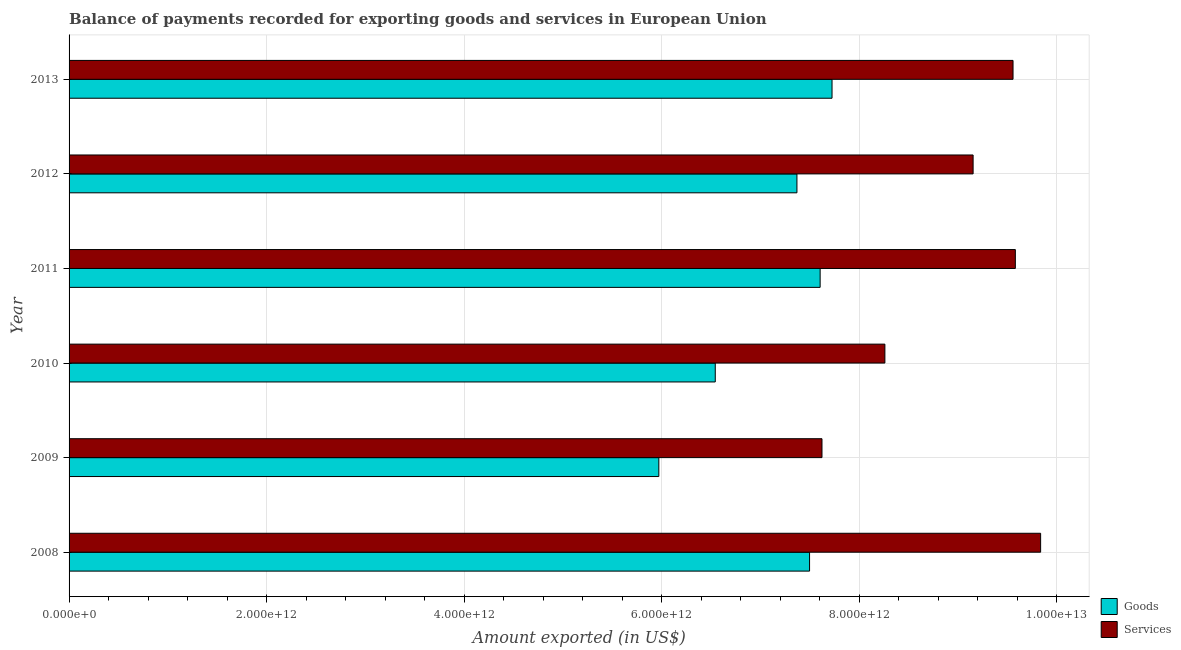Are the number of bars per tick equal to the number of legend labels?
Your answer should be very brief. Yes. How many bars are there on the 1st tick from the bottom?
Offer a terse response. 2. What is the amount of services exported in 2012?
Offer a terse response. 9.15e+12. Across all years, what is the maximum amount of services exported?
Keep it short and to the point. 9.84e+12. Across all years, what is the minimum amount of services exported?
Your response must be concise. 7.62e+12. What is the total amount of services exported in the graph?
Give a very brief answer. 5.40e+13. What is the difference between the amount of goods exported in 2011 and that in 2012?
Make the answer very short. 2.35e+11. What is the difference between the amount of goods exported in 2013 and the amount of services exported in 2011?
Your answer should be very brief. -1.86e+12. What is the average amount of goods exported per year?
Offer a terse response. 7.12e+12. In the year 2012, what is the difference between the amount of goods exported and amount of services exported?
Give a very brief answer. -1.78e+12. In how many years, is the amount of services exported greater than 6400000000000 US$?
Offer a terse response. 6. What is the ratio of the amount of services exported in 2008 to that in 2009?
Your answer should be very brief. 1.29. Is the amount of services exported in 2008 less than that in 2013?
Provide a succinct answer. No. Is the difference between the amount of services exported in 2011 and 2012 greater than the difference between the amount of goods exported in 2011 and 2012?
Keep it short and to the point. Yes. What is the difference between the highest and the second highest amount of services exported?
Provide a short and direct response. 2.56e+11. What is the difference between the highest and the lowest amount of services exported?
Give a very brief answer. 2.21e+12. Is the sum of the amount of services exported in 2008 and 2012 greater than the maximum amount of goods exported across all years?
Ensure brevity in your answer.  Yes. What does the 2nd bar from the top in 2012 represents?
Your response must be concise. Goods. What does the 2nd bar from the bottom in 2012 represents?
Provide a short and direct response. Services. How many bars are there?
Keep it short and to the point. 12. Are all the bars in the graph horizontal?
Keep it short and to the point. Yes. What is the difference between two consecutive major ticks on the X-axis?
Provide a succinct answer. 2.00e+12. Where does the legend appear in the graph?
Keep it short and to the point. Bottom right. How many legend labels are there?
Give a very brief answer. 2. How are the legend labels stacked?
Make the answer very short. Vertical. What is the title of the graph?
Your response must be concise. Balance of payments recorded for exporting goods and services in European Union. What is the label or title of the X-axis?
Offer a terse response. Amount exported (in US$). What is the Amount exported (in US$) of Goods in 2008?
Keep it short and to the point. 7.50e+12. What is the Amount exported (in US$) of Services in 2008?
Provide a succinct answer. 9.84e+12. What is the Amount exported (in US$) of Goods in 2009?
Give a very brief answer. 5.97e+12. What is the Amount exported (in US$) of Services in 2009?
Give a very brief answer. 7.62e+12. What is the Amount exported (in US$) in Goods in 2010?
Offer a very short reply. 6.54e+12. What is the Amount exported (in US$) in Services in 2010?
Ensure brevity in your answer.  8.26e+12. What is the Amount exported (in US$) in Goods in 2011?
Make the answer very short. 7.60e+12. What is the Amount exported (in US$) in Services in 2011?
Your answer should be compact. 9.58e+12. What is the Amount exported (in US$) of Goods in 2012?
Your answer should be compact. 7.37e+12. What is the Amount exported (in US$) in Services in 2012?
Give a very brief answer. 9.15e+12. What is the Amount exported (in US$) in Goods in 2013?
Provide a succinct answer. 7.72e+12. What is the Amount exported (in US$) of Services in 2013?
Your answer should be very brief. 9.56e+12. Across all years, what is the maximum Amount exported (in US$) in Goods?
Provide a succinct answer. 7.72e+12. Across all years, what is the maximum Amount exported (in US$) in Services?
Your answer should be very brief. 9.84e+12. Across all years, what is the minimum Amount exported (in US$) of Goods?
Offer a terse response. 5.97e+12. Across all years, what is the minimum Amount exported (in US$) in Services?
Make the answer very short. 7.62e+12. What is the total Amount exported (in US$) in Goods in the graph?
Give a very brief answer. 4.27e+13. What is the total Amount exported (in US$) in Services in the graph?
Make the answer very short. 5.40e+13. What is the difference between the Amount exported (in US$) of Goods in 2008 and that in 2009?
Your response must be concise. 1.53e+12. What is the difference between the Amount exported (in US$) of Services in 2008 and that in 2009?
Give a very brief answer. 2.21e+12. What is the difference between the Amount exported (in US$) in Goods in 2008 and that in 2010?
Make the answer very short. 9.54e+11. What is the difference between the Amount exported (in US$) in Services in 2008 and that in 2010?
Offer a very short reply. 1.58e+12. What is the difference between the Amount exported (in US$) in Goods in 2008 and that in 2011?
Your answer should be very brief. -1.07e+11. What is the difference between the Amount exported (in US$) of Services in 2008 and that in 2011?
Offer a terse response. 2.56e+11. What is the difference between the Amount exported (in US$) of Goods in 2008 and that in 2012?
Make the answer very short. 1.28e+11. What is the difference between the Amount exported (in US$) in Services in 2008 and that in 2012?
Ensure brevity in your answer.  6.83e+11. What is the difference between the Amount exported (in US$) in Goods in 2008 and that in 2013?
Provide a succinct answer. -2.27e+11. What is the difference between the Amount exported (in US$) in Services in 2008 and that in 2013?
Keep it short and to the point. 2.79e+11. What is the difference between the Amount exported (in US$) of Goods in 2009 and that in 2010?
Provide a succinct answer. -5.71e+11. What is the difference between the Amount exported (in US$) of Services in 2009 and that in 2010?
Your answer should be compact. -6.37e+11. What is the difference between the Amount exported (in US$) in Goods in 2009 and that in 2011?
Provide a short and direct response. -1.63e+12. What is the difference between the Amount exported (in US$) in Services in 2009 and that in 2011?
Offer a very short reply. -1.96e+12. What is the difference between the Amount exported (in US$) of Goods in 2009 and that in 2012?
Make the answer very short. -1.40e+12. What is the difference between the Amount exported (in US$) of Services in 2009 and that in 2012?
Your answer should be compact. -1.53e+12. What is the difference between the Amount exported (in US$) of Goods in 2009 and that in 2013?
Ensure brevity in your answer.  -1.75e+12. What is the difference between the Amount exported (in US$) of Services in 2009 and that in 2013?
Provide a short and direct response. -1.93e+12. What is the difference between the Amount exported (in US$) in Goods in 2010 and that in 2011?
Keep it short and to the point. -1.06e+12. What is the difference between the Amount exported (in US$) in Services in 2010 and that in 2011?
Your response must be concise. -1.32e+12. What is the difference between the Amount exported (in US$) in Goods in 2010 and that in 2012?
Offer a very short reply. -8.27e+11. What is the difference between the Amount exported (in US$) of Services in 2010 and that in 2012?
Offer a terse response. -8.93e+11. What is the difference between the Amount exported (in US$) in Goods in 2010 and that in 2013?
Offer a terse response. -1.18e+12. What is the difference between the Amount exported (in US$) in Services in 2010 and that in 2013?
Ensure brevity in your answer.  -1.30e+12. What is the difference between the Amount exported (in US$) in Goods in 2011 and that in 2012?
Your answer should be very brief. 2.35e+11. What is the difference between the Amount exported (in US$) of Services in 2011 and that in 2012?
Provide a succinct answer. 4.28e+11. What is the difference between the Amount exported (in US$) of Goods in 2011 and that in 2013?
Make the answer very short. -1.20e+11. What is the difference between the Amount exported (in US$) in Services in 2011 and that in 2013?
Provide a short and direct response. 2.33e+1. What is the difference between the Amount exported (in US$) of Goods in 2012 and that in 2013?
Your answer should be very brief. -3.55e+11. What is the difference between the Amount exported (in US$) of Services in 2012 and that in 2013?
Your response must be concise. -4.04e+11. What is the difference between the Amount exported (in US$) in Goods in 2008 and the Amount exported (in US$) in Services in 2009?
Provide a short and direct response. -1.26e+11. What is the difference between the Amount exported (in US$) in Goods in 2008 and the Amount exported (in US$) in Services in 2010?
Provide a succinct answer. -7.63e+11. What is the difference between the Amount exported (in US$) of Goods in 2008 and the Amount exported (in US$) of Services in 2011?
Your answer should be compact. -2.08e+12. What is the difference between the Amount exported (in US$) in Goods in 2008 and the Amount exported (in US$) in Services in 2012?
Keep it short and to the point. -1.66e+12. What is the difference between the Amount exported (in US$) of Goods in 2008 and the Amount exported (in US$) of Services in 2013?
Ensure brevity in your answer.  -2.06e+12. What is the difference between the Amount exported (in US$) of Goods in 2009 and the Amount exported (in US$) of Services in 2010?
Make the answer very short. -2.29e+12. What is the difference between the Amount exported (in US$) in Goods in 2009 and the Amount exported (in US$) in Services in 2011?
Ensure brevity in your answer.  -3.61e+12. What is the difference between the Amount exported (in US$) in Goods in 2009 and the Amount exported (in US$) in Services in 2012?
Provide a succinct answer. -3.18e+12. What is the difference between the Amount exported (in US$) in Goods in 2009 and the Amount exported (in US$) in Services in 2013?
Keep it short and to the point. -3.59e+12. What is the difference between the Amount exported (in US$) in Goods in 2010 and the Amount exported (in US$) in Services in 2011?
Your response must be concise. -3.04e+12. What is the difference between the Amount exported (in US$) of Goods in 2010 and the Amount exported (in US$) of Services in 2012?
Keep it short and to the point. -2.61e+12. What is the difference between the Amount exported (in US$) in Goods in 2010 and the Amount exported (in US$) in Services in 2013?
Offer a terse response. -3.01e+12. What is the difference between the Amount exported (in US$) of Goods in 2011 and the Amount exported (in US$) of Services in 2012?
Offer a terse response. -1.55e+12. What is the difference between the Amount exported (in US$) of Goods in 2011 and the Amount exported (in US$) of Services in 2013?
Offer a very short reply. -1.95e+12. What is the difference between the Amount exported (in US$) of Goods in 2012 and the Amount exported (in US$) of Services in 2013?
Your answer should be very brief. -2.19e+12. What is the average Amount exported (in US$) of Goods per year?
Your answer should be very brief. 7.12e+12. What is the average Amount exported (in US$) of Services per year?
Offer a terse response. 9.00e+12. In the year 2008, what is the difference between the Amount exported (in US$) in Goods and Amount exported (in US$) in Services?
Give a very brief answer. -2.34e+12. In the year 2009, what is the difference between the Amount exported (in US$) of Goods and Amount exported (in US$) of Services?
Your answer should be very brief. -1.65e+12. In the year 2010, what is the difference between the Amount exported (in US$) of Goods and Amount exported (in US$) of Services?
Provide a short and direct response. -1.72e+12. In the year 2011, what is the difference between the Amount exported (in US$) in Goods and Amount exported (in US$) in Services?
Give a very brief answer. -1.98e+12. In the year 2012, what is the difference between the Amount exported (in US$) of Goods and Amount exported (in US$) of Services?
Offer a terse response. -1.78e+12. In the year 2013, what is the difference between the Amount exported (in US$) in Goods and Amount exported (in US$) in Services?
Make the answer very short. -1.83e+12. What is the ratio of the Amount exported (in US$) of Goods in 2008 to that in 2009?
Provide a succinct answer. 1.26. What is the ratio of the Amount exported (in US$) of Services in 2008 to that in 2009?
Offer a very short reply. 1.29. What is the ratio of the Amount exported (in US$) of Goods in 2008 to that in 2010?
Give a very brief answer. 1.15. What is the ratio of the Amount exported (in US$) of Services in 2008 to that in 2010?
Provide a succinct answer. 1.19. What is the ratio of the Amount exported (in US$) of Goods in 2008 to that in 2011?
Your answer should be very brief. 0.99. What is the ratio of the Amount exported (in US$) in Services in 2008 to that in 2011?
Ensure brevity in your answer.  1.03. What is the ratio of the Amount exported (in US$) in Goods in 2008 to that in 2012?
Provide a succinct answer. 1.02. What is the ratio of the Amount exported (in US$) in Services in 2008 to that in 2012?
Make the answer very short. 1.07. What is the ratio of the Amount exported (in US$) of Goods in 2008 to that in 2013?
Your answer should be compact. 0.97. What is the ratio of the Amount exported (in US$) of Services in 2008 to that in 2013?
Make the answer very short. 1.03. What is the ratio of the Amount exported (in US$) of Goods in 2009 to that in 2010?
Your answer should be compact. 0.91. What is the ratio of the Amount exported (in US$) in Services in 2009 to that in 2010?
Ensure brevity in your answer.  0.92. What is the ratio of the Amount exported (in US$) of Goods in 2009 to that in 2011?
Provide a succinct answer. 0.79. What is the ratio of the Amount exported (in US$) in Services in 2009 to that in 2011?
Your response must be concise. 0.8. What is the ratio of the Amount exported (in US$) of Goods in 2009 to that in 2012?
Your answer should be very brief. 0.81. What is the ratio of the Amount exported (in US$) of Services in 2009 to that in 2012?
Provide a succinct answer. 0.83. What is the ratio of the Amount exported (in US$) of Goods in 2009 to that in 2013?
Make the answer very short. 0.77. What is the ratio of the Amount exported (in US$) in Services in 2009 to that in 2013?
Offer a very short reply. 0.8. What is the ratio of the Amount exported (in US$) in Goods in 2010 to that in 2011?
Make the answer very short. 0.86. What is the ratio of the Amount exported (in US$) of Services in 2010 to that in 2011?
Give a very brief answer. 0.86. What is the ratio of the Amount exported (in US$) of Goods in 2010 to that in 2012?
Make the answer very short. 0.89. What is the ratio of the Amount exported (in US$) in Services in 2010 to that in 2012?
Make the answer very short. 0.9. What is the ratio of the Amount exported (in US$) in Goods in 2010 to that in 2013?
Provide a succinct answer. 0.85. What is the ratio of the Amount exported (in US$) of Services in 2010 to that in 2013?
Your response must be concise. 0.86. What is the ratio of the Amount exported (in US$) of Goods in 2011 to that in 2012?
Offer a terse response. 1.03. What is the ratio of the Amount exported (in US$) of Services in 2011 to that in 2012?
Provide a succinct answer. 1.05. What is the ratio of the Amount exported (in US$) in Goods in 2011 to that in 2013?
Offer a terse response. 0.98. What is the ratio of the Amount exported (in US$) in Goods in 2012 to that in 2013?
Make the answer very short. 0.95. What is the ratio of the Amount exported (in US$) in Services in 2012 to that in 2013?
Make the answer very short. 0.96. What is the difference between the highest and the second highest Amount exported (in US$) of Goods?
Provide a succinct answer. 1.20e+11. What is the difference between the highest and the second highest Amount exported (in US$) in Services?
Provide a short and direct response. 2.56e+11. What is the difference between the highest and the lowest Amount exported (in US$) of Goods?
Ensure brevity in your answer.  1.75e+12. What is the difference between the highest and the lowest Amount exported (in US$) in Services?
Offer a terse response. 2.21e+12. 